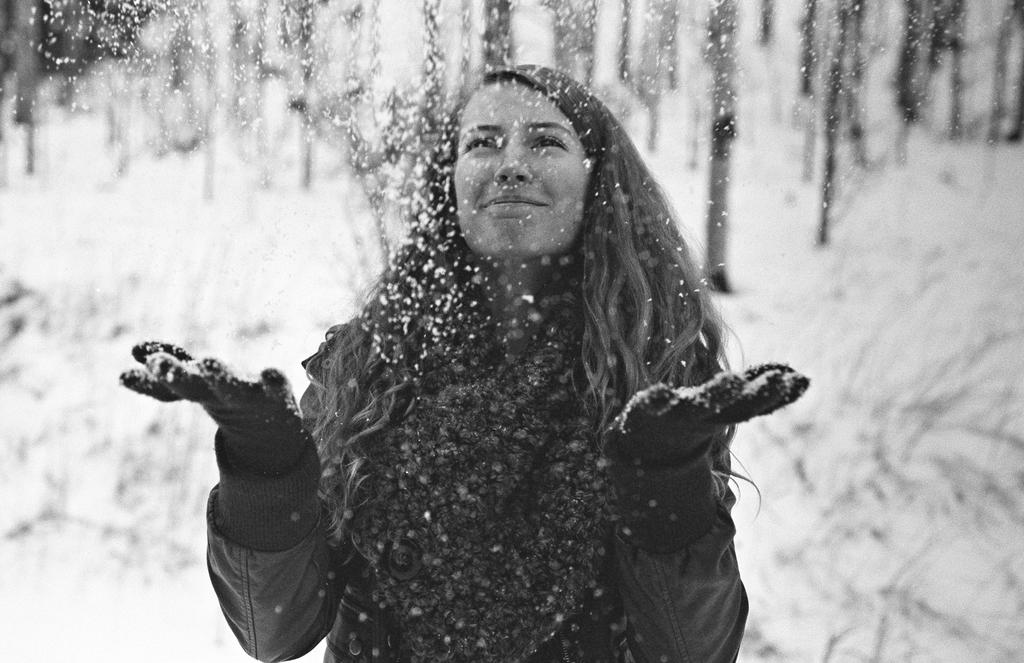Who is the main subject in the image? There is a woman in the image. What is the woman doing in the image? The woman is playing with snow. What type of clothing is the woman wearing in the image? The woman is wearing a coat. What is the color scheme of the image? The image is in black and white color. What type of whip is the actor using in the image? There is no actor or whip present in the image; it features a woman playing with snow. 